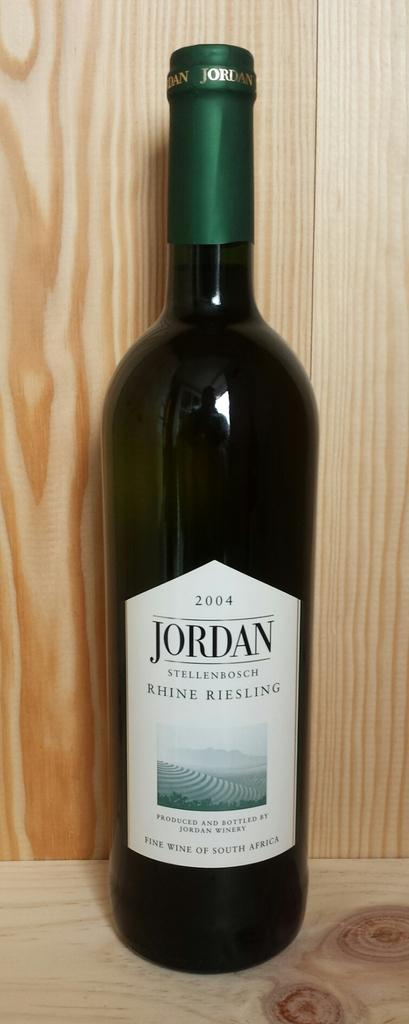What is located in the foreground of the image? There is a bottle in the foreground of the image. What is the bottle placed on? The bottle is on a wooden surface. What can be seen in the background of the image? There is a wooden wall-like structure in the background of the image. What type of comb is being used in the battle depicted in the image? There is no battle or comb present in the image; it features a bottle on a wooden surface with a wooden wall-like structure in the background. 